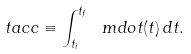<formula> <loc_0><loc_0><loc_500><loc_500>\ t a c c \equiv \int _ { t _ { i } } ^ { t _ { f } } \ m d o t ( t ) \, d t .</formula> 